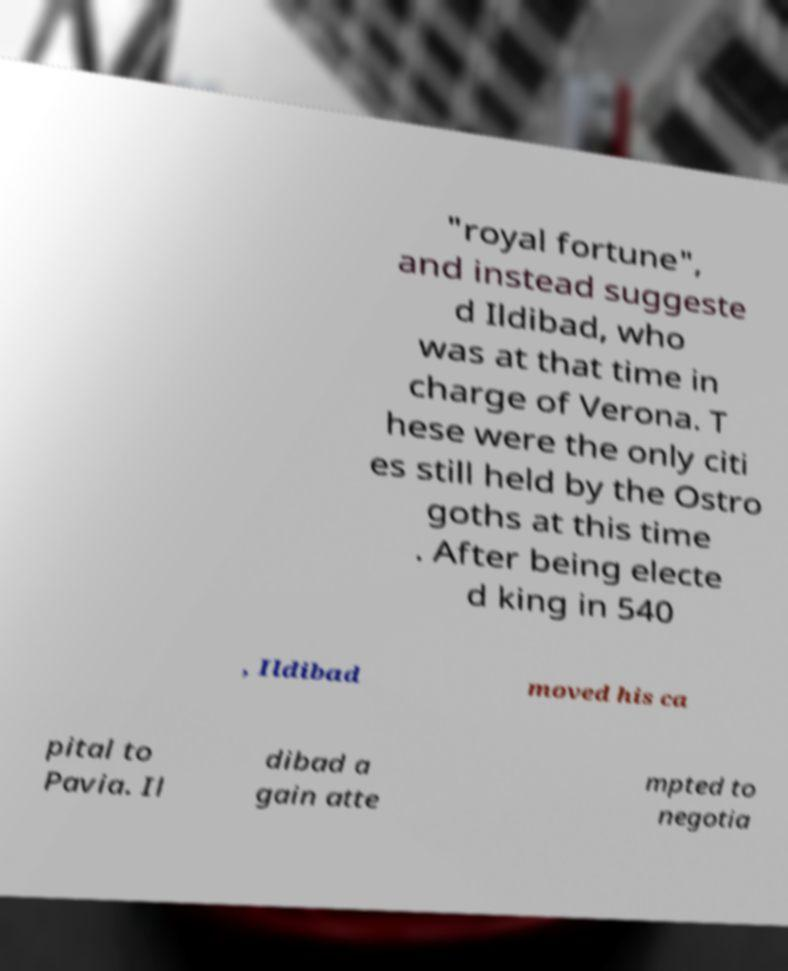Can you accurately transcribe the text from the provided image for me? "royal fortune", and instead suggeste d Ildibad, who was at that time in charge of Verona. T hese were the only citi es still held by the Ostro goths at this time . After being electe d king in 540 , Ildibad moved his ca pital to Pavia. Il dibad a gain atte mpted to negotia 